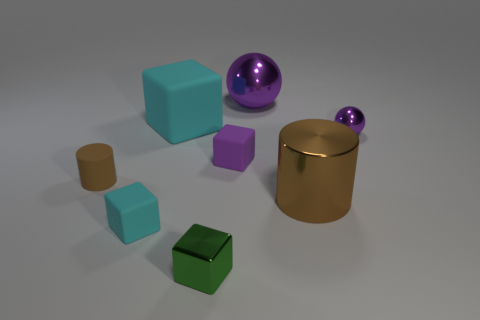Subtract all purple blocks. Subtract all green spheres. How many blocks are left? 3 Add 1 brown matte objects. How many objects exist? 9 Subtract all balls. How many objects are left? 6 Add 6 gray shiny balls. How many gray shiny balls exist? 6 Subtract 0 yellow balls. How many objects are left? 8 Subtract all rubber cylinders. Subtract all rubber balls. How many objects are left? 7 Add 2 big brown shiny objects. How many big brown shiny objects are left? 3 